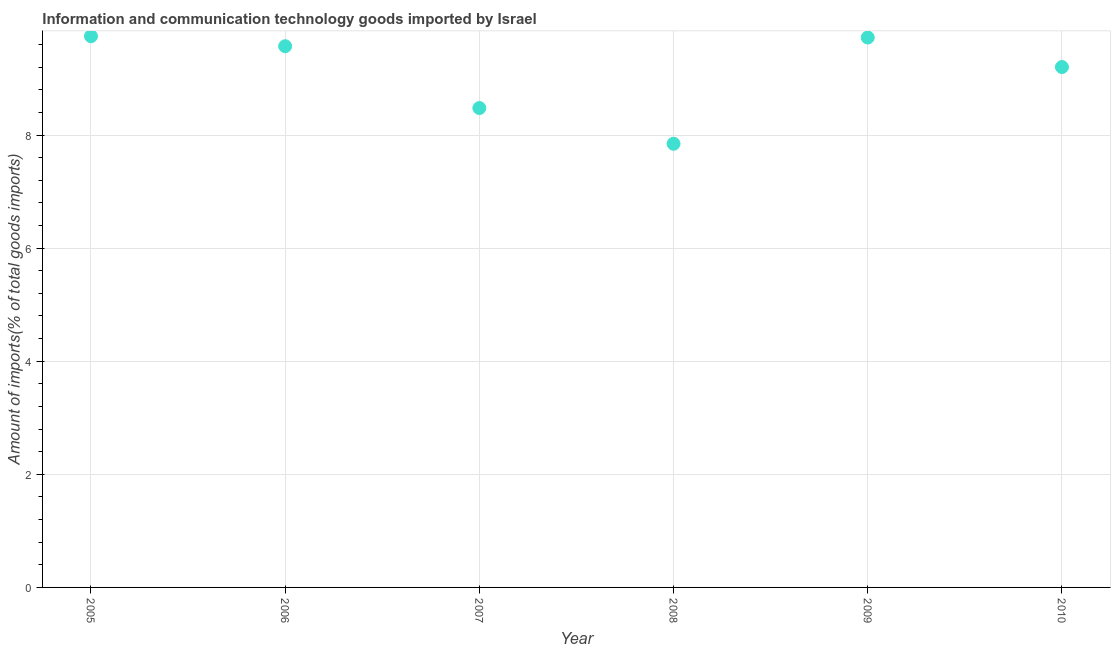What is the amount of ict goods imports in 2008?
Give a very brief answer. 7.85. Across all years, what is the maximum amount of ict goods imports?
Offer a very short reply. 9.75. Across all years, what is the minimum amount of ict goods imports?
Keep it short and to the point. 7.85. In which year was the amount of ict goods imports maximum?
Your response must be concise. 2005. In which year was the amount of ict goods imports minimum?
Make the answer very short. 2008. What is the sum of the amount of ict goods imports?
Give a very brief answer. 54.56. What is the difference between the amount of ict goods imports in 2008 and 2009?
Provide a short and direct response. -1.88. What is the average amount of ict goods imports per year?
Offer a very short reply. 9.09. What is the median amount of ict goods imports?
Make the answer very short. 9.39. In how many years, is the amount of ict goods imports greater than 0.8 %?
Offer a terse response. 6. What is the ratio of the amount of ict goods imports in 2005 to that in 2007?
Keep it short and to the point. 1.15. Is the amount of ict goods imports in 2007 less than that in 2010?
Offer a very short reply. Yes. What is the difference between the highest and the second highest amount of ict goods imports?
Give a very brief answer. 0.02. Is the sum of the amount of ict goods imports in 2006 and 2009 greater than the maximum amount of ict goods imports across all years?
Offer a terse response. Yes. What is the difference between the highest and the lowest amount of ict goods imports?
Provide a short and direct response. 1.9. In how many years, is the amount of ict goods imports greater than the average amount of ict goods imports taken over all years?
Your answer should be compact. 4. How many dotlines are there?
Make the answer very short. 1. How many years are there in the graph?
Provide a succinct answer. 6. Are the values on the major ticks of Y-axis written in scientific E-notation?
Offer a very short reply. No. What is the title of the graph?
Offer a terse response. Information and communication technology goods imported by Israel. What is the label or title of the Y-axis?
Your answer should be compact. Amount of imports(% of total goods imports). What is the Amount of imports(% of total goods imports) in 2005?
Ensure brevity in your answer.  9.75. What is the Amount of imports(% of total goods imports) in 2006?
Your answer should be compact. 9.57. What is the Amount of imports(% of total goods imports) in 2007?
Give a very brief answer. 8.48. What is the Amount of imports(% of total goods imports) in 2008?
Provide a short and direct response. 7.85. What is the Amount of imports(% of total goods imports) in 2009?
Ensure brevity in your answer.  9.72. What is the Amount of imports(% of total goods imports) in 2010?
Provide a short and direct response. 9.2. What is the difference between the Amount of imports(% of total goods imports) in 2005 and 2006?
Your response must be concise. 0.18. What is the difference between the Amount of imports(% of total goods imports) in 2005 and 2007?
Give a very brief answer. 1.27. What is the difference between the Amount of imports(% of total goods imports) in 2005 and 2008?
Provide a succinct answer. 1.9. What is the difference between the Amount of imports(% of total goods imports) in 2005 and 2009?
Provide a succinct answer. 0.02. What is the difference between the Amount of imports(% of total goods imports) in 2005 and 2010?
Make the answer very short. 0.55. What is the difference between the Amount of imports(% of total goods imports) in 2006 and 2007?
Your answer should be compact. 1.09. What is the difference between the Amount of imports(% of total goods imports) in 2006 and 2008?
Your answer should be very brief. 1.72. What is the difference between the Amount of imports(% of total goods imports) in 2006 and 2009?
Your answer should be very brief. -0.15. What is the difference between the Amount of imports(% of total goods imports) in 2006 and 2010?
Your answer should be compact. 0.37. What is the difference between the Amount of imports(% of total goods imports) in 2007 and 2008?
Your answer should be very brief. 0.63. What is the difference between the Amount of imports(% of total goods imports) in 2007 and 2009?
Offer a very short reply. -1.25. What is the difference between the Amount of imports(% of total goods imports) in 2007 and 2010?
Provide a short and direct response. -0.72. What is the difference between the Amount of imports(% of total goods imports) in 2008 and 2009?
Offer a very short reply. -1.88. What is the difference between the Amount of imports(% of total goods imports) in 2008 and 2010?
Your answer should be compact. -1.36. What is the difference between the Amount of imports(% of total goods imports) in 2009 and 2010?
Make the answer very short. 0.52. What is the ratio of the Amount of imports(% of total goods imports) in 2005 to that in 2007?
Keep it short and to the point. 1.15. What is the ratio of the Amount of imports(% of total goods imports) in 2005 to that in 2008?
Provide a succinct answer. 1.24. What is the ratio of the Amount of imports(% of total goods imports) in 2005 to that in 2010?
Offer a very short reply. 1.06. What is the ratio of the Amount of imports(% of total goods imports) in 2006 to that in 2007?
Your answer should be compact. 1.13. What is the ratio of the Amount of imports(% of total goods imports) in 2006 to that in 2008?
Offer a terse response. 1.22. What is the ratio of the Amount of imports(% of total goods imports) in 2006 to that in 2009?
Offer a very short reply. 0.98. What is the ratio of the Amount of imports(% of total goods imports) in 2007 to that in 2009?
Provide a short and direct response. 0.87. What is the ratio of the Amount of imports(% of total goods imports) in 2007 to that in 2010?
Provide a short and direct response. 0.92. What is the ratio of the Amount of imports(% of total goods imports) in 2008 to that in 2009?
Your answer should be compact. 0.81. What is the ratio of the Amount of imports(% of total goods imports) in 2008 to that in 2010?
Make the answer very short. 0.85. What is the ratio of the Amount of imports(% of total goods imports) in 2009 to that in 2010?
Ensure brevity in your answer.  1.06. 